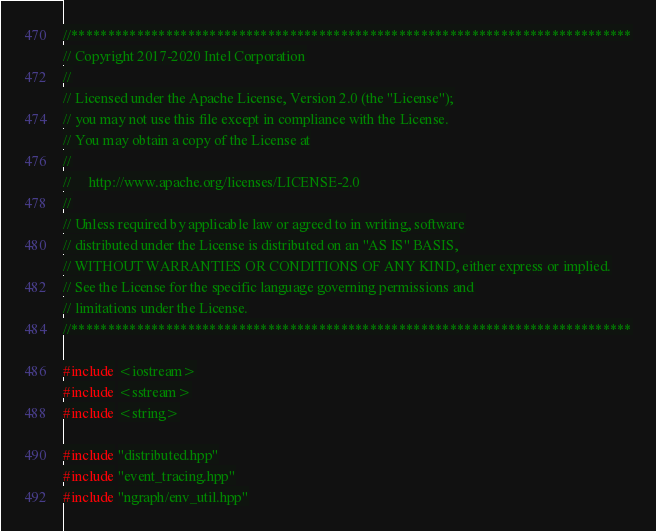<code> <loc_0><loc_0><loc_500><loc_500><_C++_>//*****************************************************************************
// Copyright 2017-2020 Intel Corporation
//
// Licensed under the Apache License, Version 2.0 (the "License");
// you may not use this file except in compliance with the License.
// You may obtain a copy of the License at
//
//     http://www.apache.org/licenses/LICENSE-2.0
//
// Unless required by applicable law or agreed to in writing, software
// distributed under the License is distributed on an "AS IS" BASIS,
// WITHOUT WARRANTIES OR CONDITIONS OF ANY KIND, either express or implied.
// See the License for the specific language governing permissions and
// limitations under the License.
//*****************************************************************************

#include <iostream>
#include <sstream>
#include <string>

#include "distributed.hpp"
#include "event_tracing.hpp"
#include "ngraph/env_util.hpp"</code> 